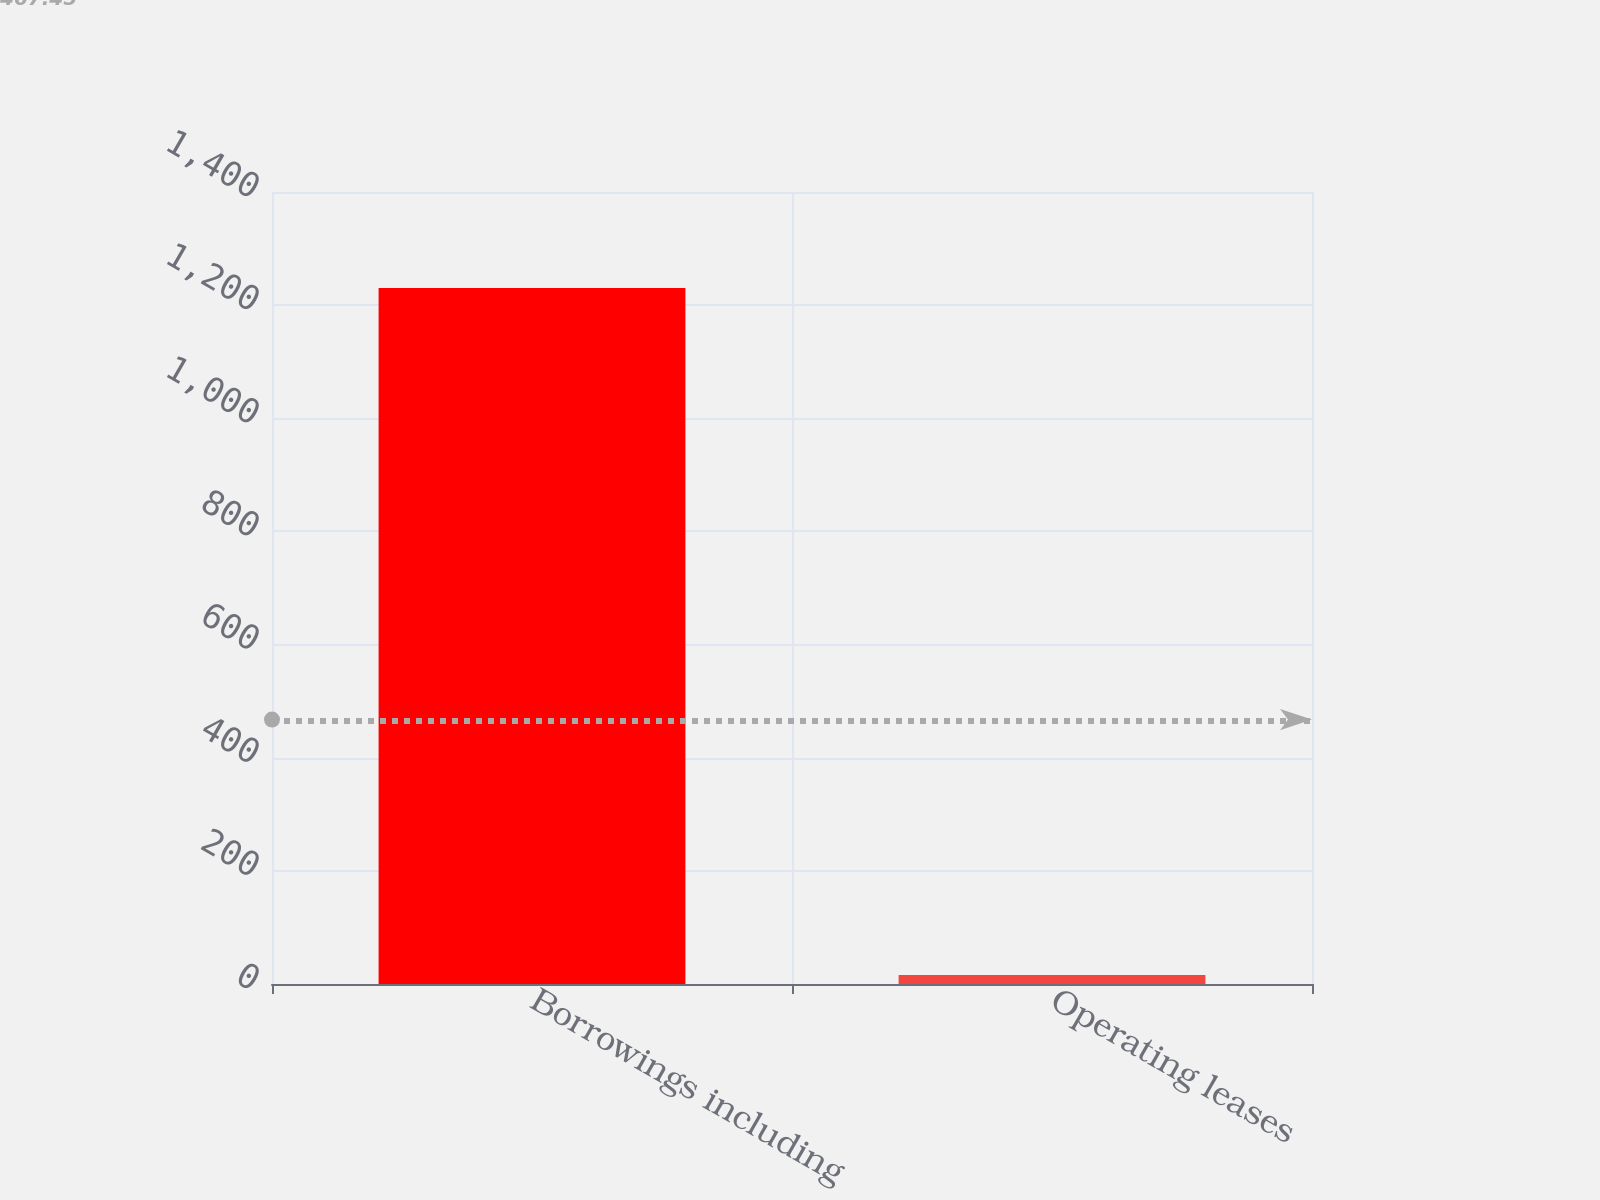Convert chart to OTSL. <chart><loc_0><loc_0><loc_500><loc_500><bar_chart><fcel>Borrowings including<fcel>Operating leases<nl><fcel>1230.2<fcel>16.1<nl></chart> 